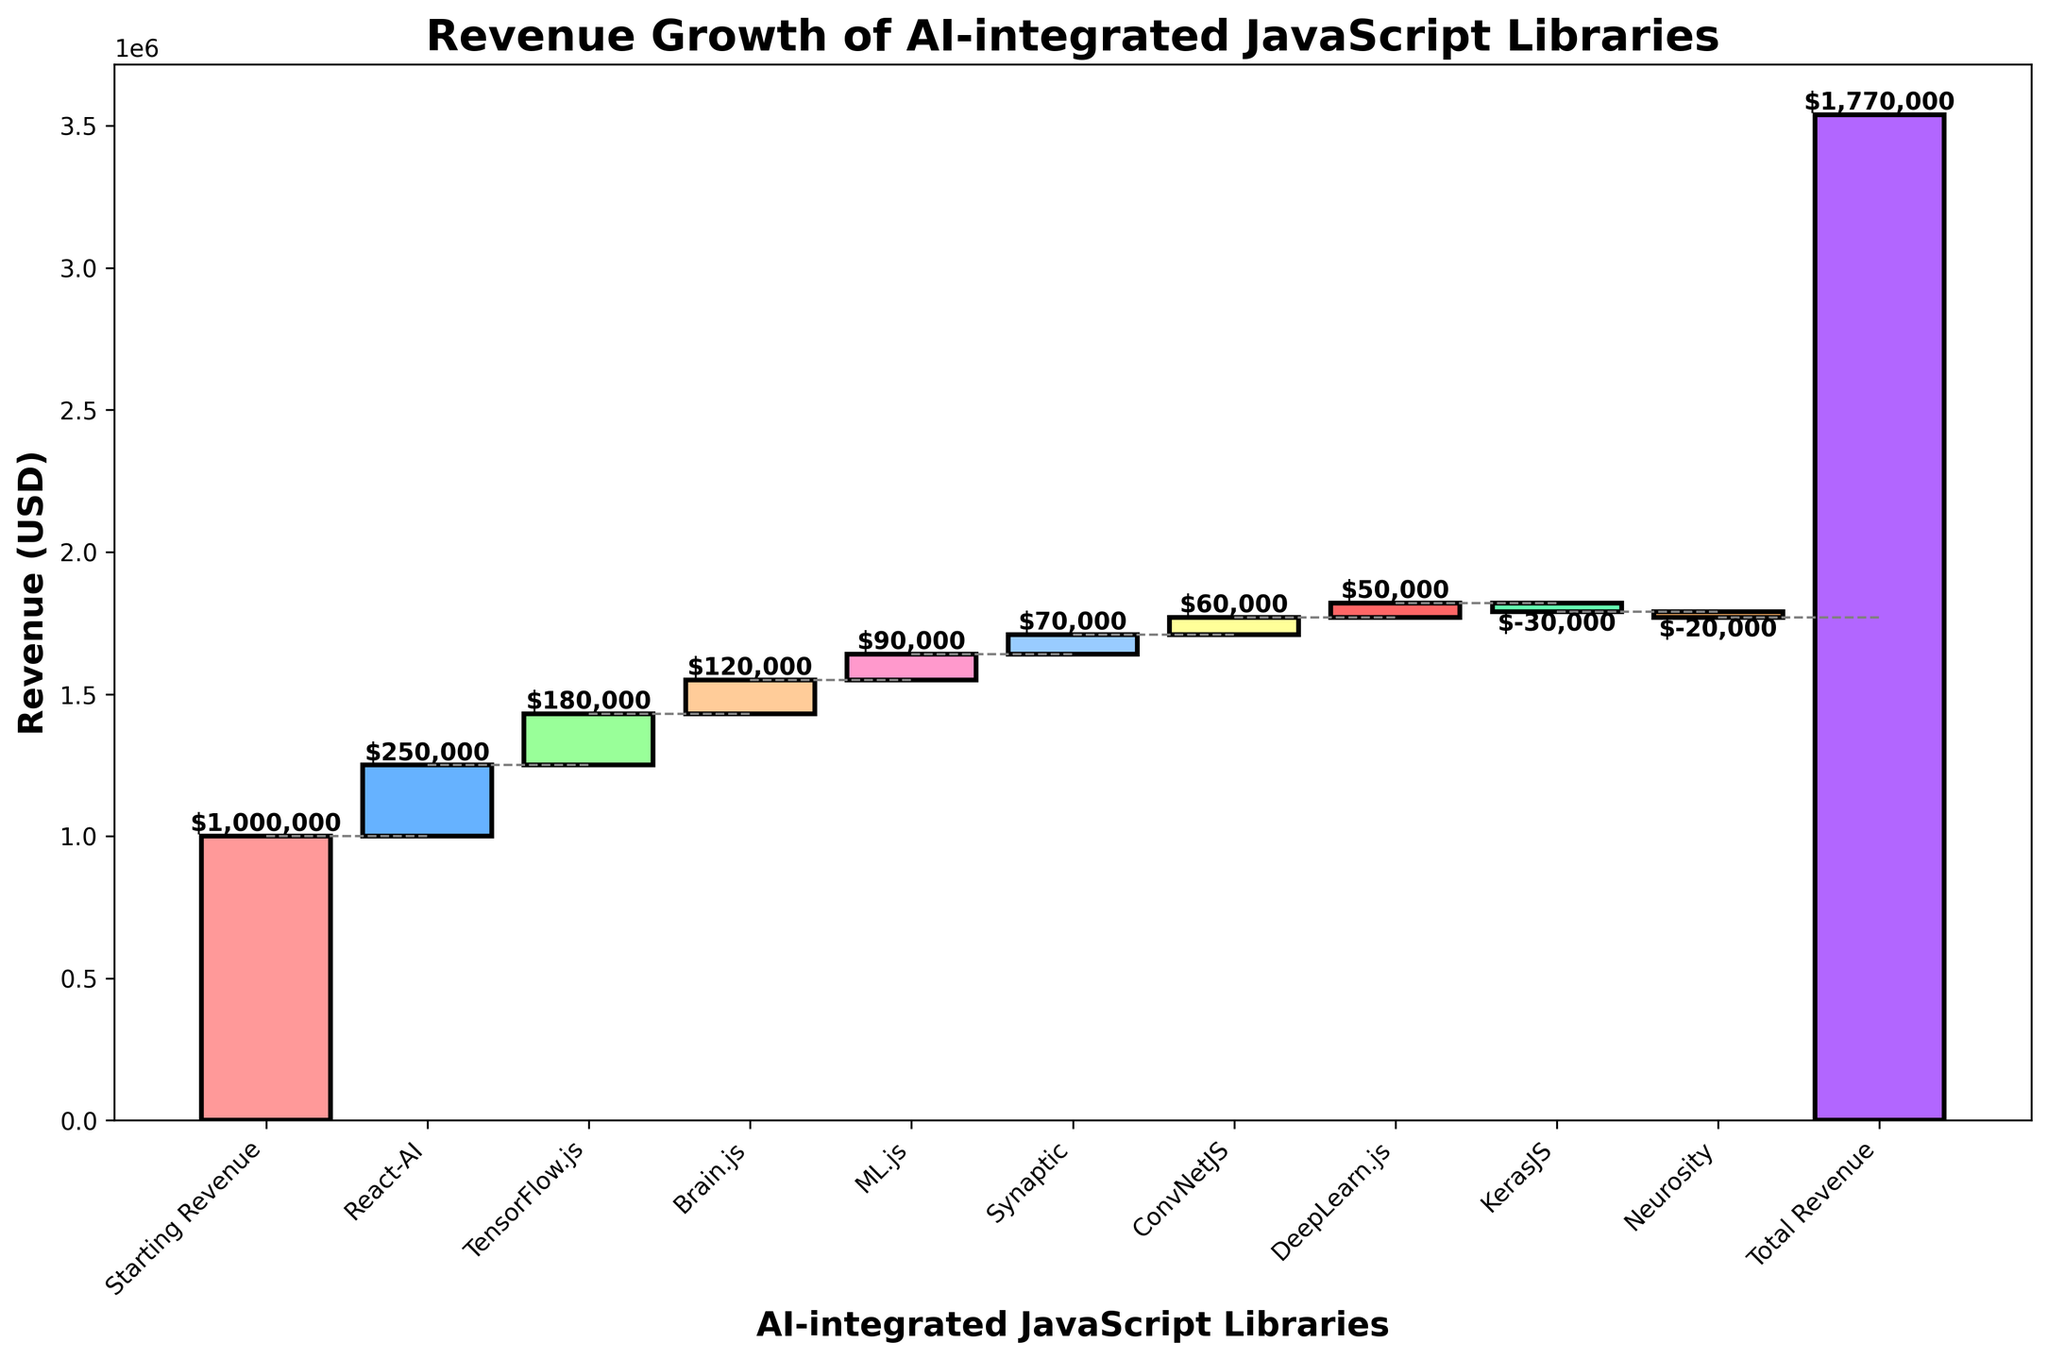What's the title of the chart? The title of the chart is located at the top of the figure and states the main topic the chart is about.
Answer: Revenue Growth of AI-integrated JavaScript Libraries How much is the revenue contribution from TensorFlow.js? To find this, locate TensorFlow.js on the x-axis and look at the corresponding bar to see its value.
Answer: $180,000 Which product has the most negative impact on revenue? Look for the product with the lowest bar value. The product with the bar showing a decrease in value compared to others will have the most negative impact.
Answer: KerasJS What's the cumulative revenue after adding ML.js contributions? First, find ML.js on the x-axis, then check the cumulative revenue value after this addition by looking at where the bar ends (top value of that bar).
Answer: $1,640,000 Which product generated more revenue, Brain.js or ConvNetJS? Compare the heights of the bars of Brain.js and ConvNetJS. The higher bar represents greater revenue.
Answer: Brain.js What's the net increase in revenue from the starting revenue to the total revenue? Subtract the starting revenue value from the total revenue value. Starting revenue is $1,000,000 and total revenue is $1,770,000. 1,770,000 - 1,000,000 = 770,000.
Answer: $770,000 How does Neurosity’s contribution compare to Synaptic’s? Compare the heights of the bars of Neurosity and Synaptic. Neurosity has a negative value, while Synaptic has a positive value, indicating Synaptic contributed more.
Answer: Synaptic contributed more What are the cumulative revenues just before and after the contribution of DeepLearn.js? Look at the cumulative sum just before DeepLearn.js and then right after its contribution by checking the bar's top value. Cumulative before is $1,650,000 and cumulative after is $1,700,000.
Answer: Before: $1,650,000; After: $1,700,000 Which two products contributed similarly to the revenue, and how do their contributions compare? Look for two products with similar bar heights. Brain.js and ML.js have similar contributions with Brain.js at $120,000 and ML.js at $90,000.
Answer: Brain.js and ML.js, Brain.js contributed $30,000 more 